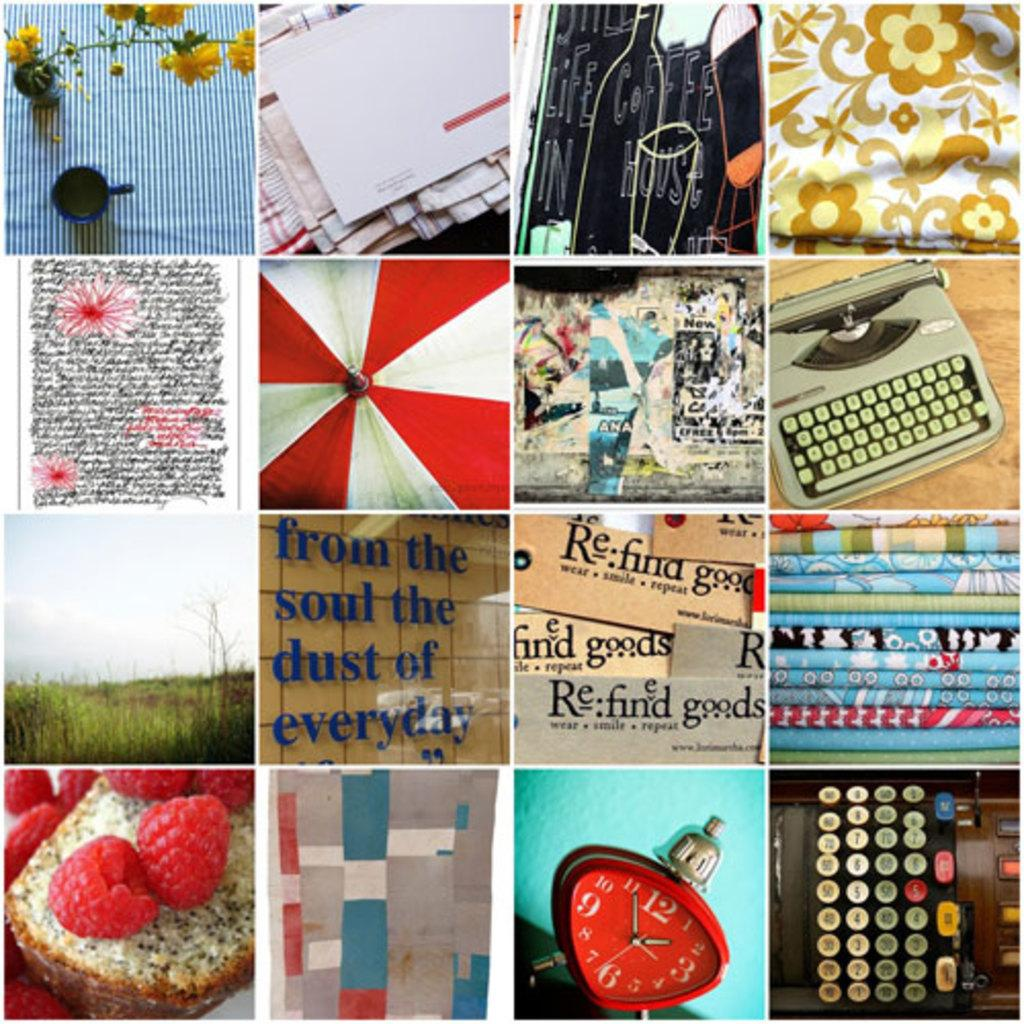<image>
Give a short and clear explanation of the subsequent image. A collage of 16 photos shows many things, including raspberries, fabric, and a sign that say from the soul the dust of everyday. 